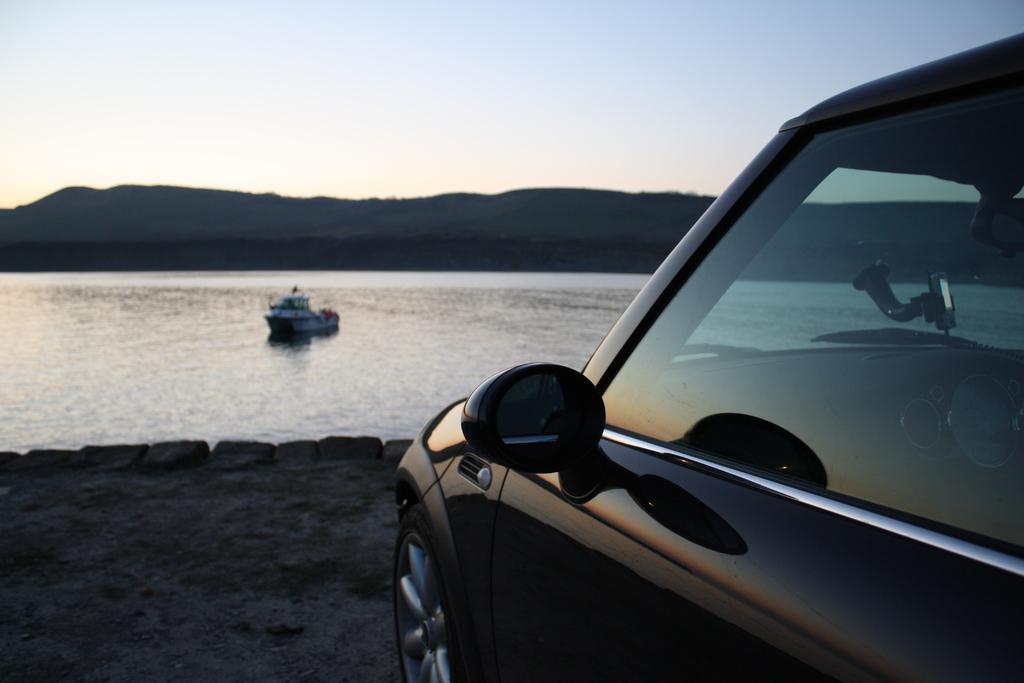Could you give a brief overview of what you see in this image? In the front of the image there is a vehicle. In the background of the image there is a hill, water, boat and the sky.  